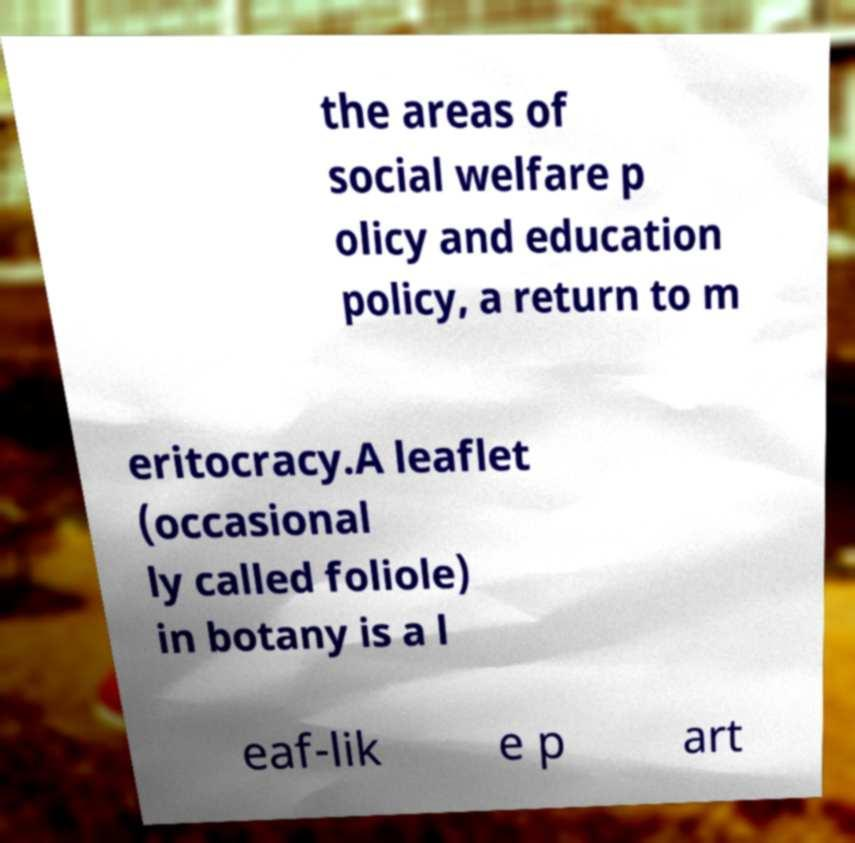Could you extract and type out the text from this image? the areas of social welfare p olicy and education policy, a return to m eritocracy.A leaflet (occasional ly called foliole) in botany is a l eaf-lik e p art 